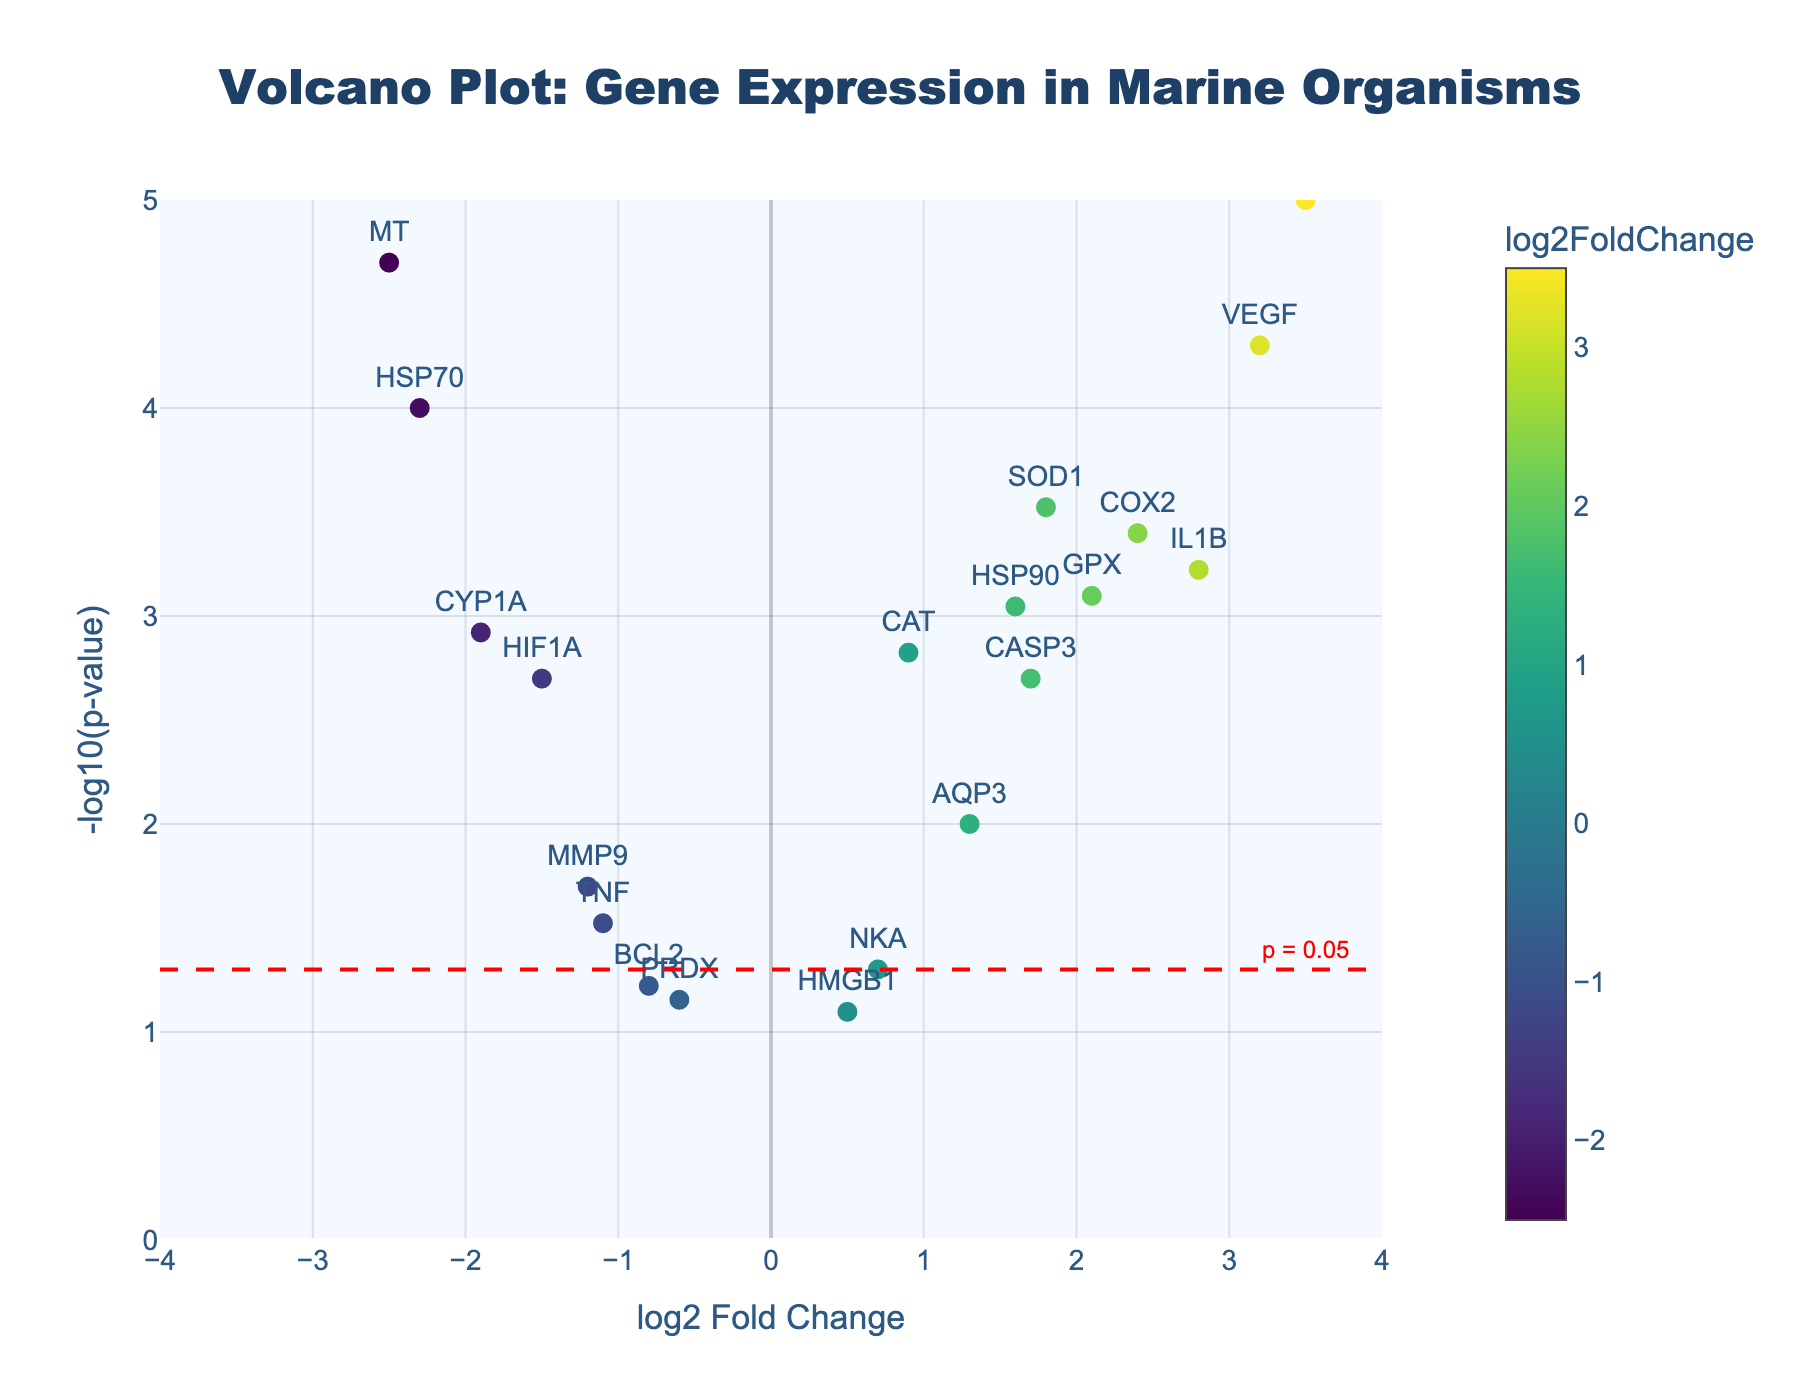what is the title of the plot? The title of the plot is found at the top center of the figure. The exact text reads "Volcano Plot: Gene Expression in Marine Organisms."
Answer: Volcano Plot: Gene Expression in Marine Organisms What do the x-axis and y-axis represent? The x-axis title reads "log2 Fold Change," and the y-axis title reads "-log10(p-value)." The x-axis represents the log2 fold change in gene expression, and the y-axis represents the negative log10 of the p-value.
Answer: log2 Fold Change, -log10(p-value) Which gene has the highest log2 fold change? Look for the gene labeled next to the highest value on the x-axis. From the figure, "GSTA" is located at the position where the log2 fold change is the highest.
Answer: GSTA How many data points have a p-value less than 0.05? Data points above the dashed red line (p = 0.05) on the plot have p-values less than 0.05. From observation, there are 15 data points above this line.
Answer: 15 Which gene exhibits the most significant change (lowest p-value)? The most significant change corresponds to the highest y-axis value (-log10(p-value)). The gene "GSTA" is located at this highest y-axis position.
Answer: GSTA What is the range of log2 fold change values? The x-axis range extends from -4 to 4. This indicates the log2 fold change values span from -4 to 4.
Answer: -4 to 4 Which genes have both a log2 fold change greater than 2 and a p-value less than 0.001? Find data points with x-axis values greater than 2 and corresponding y-axis values above -log10(0.001) ≈ 3. These genes are "VEGF," "COX2," and "GSTA."
Answer: VEGF, COX2, GSTA How is the statistical significance threshold visually represented in the plot? The significance threshold is shown with a dashed red line drawn horizontally at y = -log10(0.05) and is annotated with the text "p = 0.05."
Answer: A dashed red line and annotation "p = 0.05" What colors are used to represent the log2 fold change and how are they scaled? The color scale is 'Viridis' and is used to represent the log2 fold change. The colors range from cooler colors (representing lower values) to warmer colors (representing higher values).
Answer: Viridis scale Which genes are downregulated with a p-value less than 0.001? Downregulated genes have negative log2 fold change values and their data points are above -log10(0.001) on the y-axis. There are two such genes: "HSP70" and "MT."
Answer: HSP70, MT 